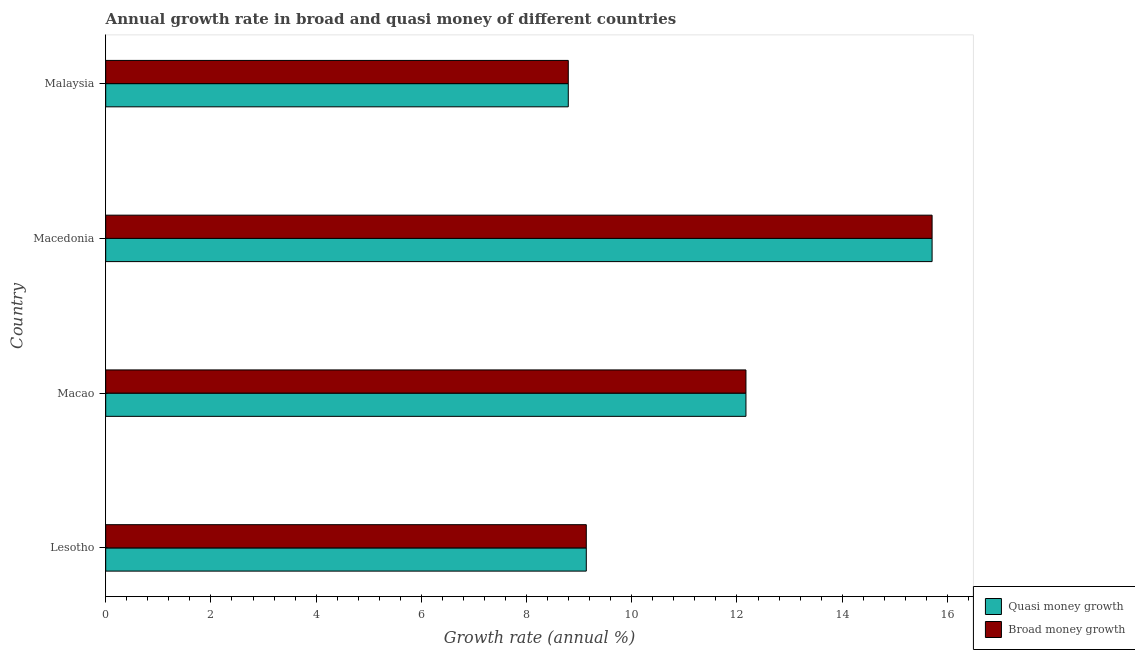How many groups of bars are there?
Give a very brief answer. 4. Are the number of bars per tick equal to the number of legend labels?
Provide a succinct answer. Yes. How many bars are there on the 2nd tick from the top?
Make the answer very short. 2. How many bars are there on the 4th tick from the bottom?
Make the answer very short. 2. What is the label of the 1st group of bars from the top?
Keep it short and to the point. Malaysia. What is the annual growth rate in quasi money in Macao?
Provide a short and direct response. 12.17. Across all countries, what is the maximum annual growth rate in broad money?
Keep it short and to the point. 15.71. Across all countries, what is the minimum annual growth rate in broad money?
Provide a short and direct response. 8.79. In which country was the annual growth rate in broad money maximum?
Your response must be concise. Macedonia. In which country was the annual growth rate in broad money minimum?
Ensure brevity in your answer.  Malaysia. What is the total annual growth rate in quasi money in the graph?
Offer a very short reply. 45.81. What is the difference between the annual growth rate in quasi money in Lesotho and that in Macedonia?
Keep it short and to the point. -6.57. What is the difference between the annual growth rate in quasi money in Macao and the annual growth rate in broad money in Lesotho?
Provide a succinct answer. 3.03. What is the average annual growth rate in quasi money per country?
Your response must be concise. 11.45. What is the difference between the annual growth rate in broad money and annual growth rate in quasi money in Macedonia?
Your response must be concise. 0. In how many countries, is the annual growth rate in broad money greater than 11.6 %?
Make the answer very short. 2. What is the ratio of the annual growth rate in quasi money in Lesotho to that in Macao?
Offer a terse response. 0.75. What is the difference between the highest and the second highest annual growth rate in broad money?
Give a very brief answer. 3.54. What is the difference between the highest and the lowest annual growth rate in broad money?
Offer a terse response. 6.92. What does the 2nd bar from the top in Malaysia represents?
Give a very brief answer. Quasi money growth. What does the 1st bar from the bottom in Macao represents?
Give a very brief answer. Quasi money growth. Are all the bars in the graph horizontal?
Offer a terse response. Yes. How many countries are there in the graph?
Offer a very short reply. 4. What is the difference between two consecutive major ticks on the X-axis?
Your response must be concise. 2. Are the values on the major ticks of X-axis written in scientific E-notation?
Your answer should be very brief. No. Does the graph contain any zero values?
Your answer should be very brief. No. Does the graph contain grids?
Provide a short and direct response. No. Where does the legend appear in the graph?
Give a very brief answer. Bottom right. How many legend labels are there?
Keep it short and to the point. 2. How are the legend labels stacked?
Keep it short and to the point. Vertical. What is the title of the graph?
Provide a short and direct response. Annual growth rate in broad and quasi money of different countries. Does "Goods" appear as one of the legend labels in the graph?
Your answer should be compact. No. What is the label or title of the X-axis?
Keep it short and to the point. Growth rate (annual %). What is the label or title of the Y-axis?
Your answer should be very brief. Country. What is the Growth rate (annual %) of Quasi money growth in Lesotho?
Your answer should be very brief. 9.14. What is the Growth rate (annual %) in Broad money growth in Lesotho?
Give a very brief answer. 9.14. What is the Growth rate (annual %) of Quasi money growth in Macao?
Give a very brief answer. 12.17. What is the Growth rate (annual %) of Broad money growth in Macao?
Offer a very short reply. 12.17. What is the Growth rate (annual %) of Quasi money growth in Macedonia?
Ensure brevity in your answer.  15.71. What is the Growth rate (annual %) in Broad money growth in Macedonia?
Offer a terse response. 15.71. What is the Growth rate (annual %) in Quasi money growth in Malaysia?
Offer a very short reply. 8.79. What is the Growth rate (annual %) in Broad money growth in Malaysia?
Offer a very short reply. 8.79. Across all countries, what is the maximum Growth rate (annual %) of Quasi money growth?
Offer a terse response. 15.71. Across all countries, what is the maximum Growth rate (annual %) in Broad money growth?
Offer a terse response. 15.71. Across all countries, what is the minimum Growth rate (annual %) of Quasi money growth?
Keep it short and to the point. 8.79. Across all countries, what is the minimum Growth rate (annual %) of Broad money growth?
Give a very brief answer. 8.79. What is the total Growth rate (annual %) in Quasi money growth in the graph?
Your answer should be compact. 45.81. What is the total Growth rate (annual %) in Broad money growth in the graph?
Offer a very short reply. 45.81. What is the difference between the Growth rate (annual %) in Quasi money growth in Lesotho and that in Macao?
Give a very brief answer. -3.03. What is the difference between the Growth rate (annual %) of Broad money growth in Lesotho and that in Macao?
Offer a terse response. -3.03. What is the difference between the Growth rate (annual %) in Quasi money growth in Lesotho and that in Macedonia?
Your answer should be compact. -6.57. What is the difference between the Growth rate (annual %) in Broad money growth in Lesotho and that in Macedonia?
Provide a short and direct response. -6.57. What is the difference between the Growth rate (annual %) in Quasi money growth in Lesotho and that in Malaysia?
Keep it short and to the point. 0.34. What is the difference between the Growth rate (annual %) in Broad money growth in Lesotho and that in Malaysia?
Provide a short and direct response. 0.34. What is the difference between the Growth rate (annual %) in Quasi money growth in Macao and that in Macedonia?
Offer a terse response. -3.54. What is the difference between the Growth rate (annual %) of Broad money growth in Macao and that in Macedonia?
Ensure brevity in your answer.  -3.54. What is the difference between the Growth rate (annual %) of Quasi money growth in Macao and that in Malaysia?
Give a very brief answer. 3.38. What is the difference between the Growth rate (annual %) of Broad money growth in Macao and that in Malaysia?
Keep it short and to the point. 3.38. What is the difference between the Growth rate (annual %) of Quasi money growth in Macedonia and that in Malaysia?
Keep it short and to the point. 6.92. What is the difference between the Growth rate (annual %) of Broad money growth in Macedonia and that in Malaysia?
Provide a succinct answer. 6.92. What is the difference between the Growth rate (annual %) in Quasi money growth in Lesotho and the Growth rate (annual %) in Broad money growth in Macao?
Ensure brevity in your answer.  -3.03. What is the difference between the Growth rate (annual %) of Quasi money growth in Lesotho and the Growth rate (annual %) of Broad money growth in Macedonia?
Offer a very short reply. -6.57. What is the difference between the Growth rate (annual %) in Quasi money growth in Lesotho and the Growth rate (annual %) in Broad money growth in Malaysia?
Keep it short and to the point. 0.34. What is the difference between the Growth rate (annual %) of Quasi money growth in Macao and the Growth rate (annual %) of Broad money growth in Macedonia?
Make the answer very short. -3.54. What is the difference between the Growth rate (annual %) in Quasi money growth in Macao and the Growth rate (annual %) in Broad money growth in Malaysia?
Ensure brevity in your answer.  3.38. What is the difference between the Growth rate (annual %) in Quasi money growth in Macedonia and the Growth rate (annual %) in Broad money growth in Malaysia?
Make the answer very short. 6.92. What is the average Growth rate (annual %) in Quasi money growth per country?
Offer a very short reply. 11.45. What is the average Growth rate (annual %) in Broad money growth per country?
Offer a terse response. 11.45. What is the difference between the Growth rate (annual %) of Quasi money growth and Growth rate (annual %) of Broad money growth in Macao?
Your answer should be compact. 0. What is the difference between the Growth rate (annual %) in Quasi money growth and Growth rate (annual %) in Broad money growth in Macedonia?
Your response must be concise. 0. What is the difference between the Growth rate (annual %) in Quasi money growth and Growth rate (annual %) in Broad money growth in Malaysia?
Keep it short and to the point. 0. What is the ratio of the Growth rate (annual %) of Quasi money growth in Lesotho to that in Macao?
Your answer should be compact. 0.75. What is the ratio of the Growth rate (annual %) in Broad money growth in Lesotho to that in Macao?
Provide a succinct answer. 0.75. What is the ratio of the Growth rate (annual %) in Quasi money growth in Lesotho to that in Macedonia?
Offer a terse response. 0.58. What is the ratio of the Growth rate (annual %) in Broad money growth in Lesotho to that in Macedonia?
Offer a terse response. 0.58. What is the ratio of the Growth rate (annual %) in Quasi money growth in Lesotho to that in Malaysia?
Offer a very short reply. 1.04. What is the ratio of the Growth rate (annual %) of Broad money growth in Lesotho to that in Malaysia?
Give a very brief answer. 1.04. What is the ratio of the Growth rate (annual %) of Quasi money growth in Macao to that in Macedonia?
Keep it short and to the point. 0.77. What is the ratio of the Growth rate (annual %) of Broad money growth in Macao to that in Macedonia?
Your answer should be very brief. 0.77. What is the ratio of the Growth rate (annual %) in Quasi money growth in Macao to that in Malaysia?
Provide a succinct answer. 1.38. What is the ratio of the Growth rate (annual %) of Broad money growth in Macao to that in Malaysia?
Offer a very short reply. 1.38. What is the ratio of the Growth rate (annual %) in Quasi money growth in Macedonia to that in Malaysia?
Provide a succinct answer. 1.79. What is the ratio of the Growth rate (annual %) in Broad money growth in Macedonia to that in Malaysia?
Keep it short and to the point. 1.79. What is the difference between the highest and the second highest Growth rate (annual %) of Quasi money growth?
Give a very brief answer. 3.54. What is the difference between the highest and the second highest Growth rate (annual %) of Broad money growth?
Make the answer very short. 3.54. What is the difference between the highest and the lowest Growth rate (annual %) of Quasi money growth?
Make the answer very short. 6.92. What is the difference between the highest and the lowest Growth rate (annual %) in Broad money growth?
Provide a succinct answer. 6.92. 